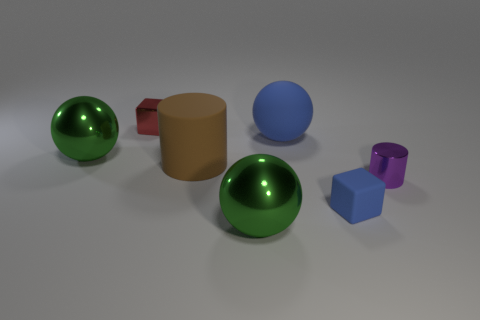Subtract all big metallic spheres. How many spheres are left? 1 Add 2 blue rubber spheres. How many objects exist? 9 Subtract all blue spheres. How many spheres are left? 2 Subtract all balls. How many objects are left? 4 Subtract all gray blocks. How many purple balls are left? 0 Subtract all rubber blocks. Subtract all cubes. How many objects are left? 4 Add 6 red metallic cubes. How many red metallic cubes are left? 7 Add 7 big blue rubber blocks. How many big blue rubber blocks exist? 7 Subtract 1 red blocks. How many objects are left? 6 Subtract 1 balls. How many balls are left? 2 